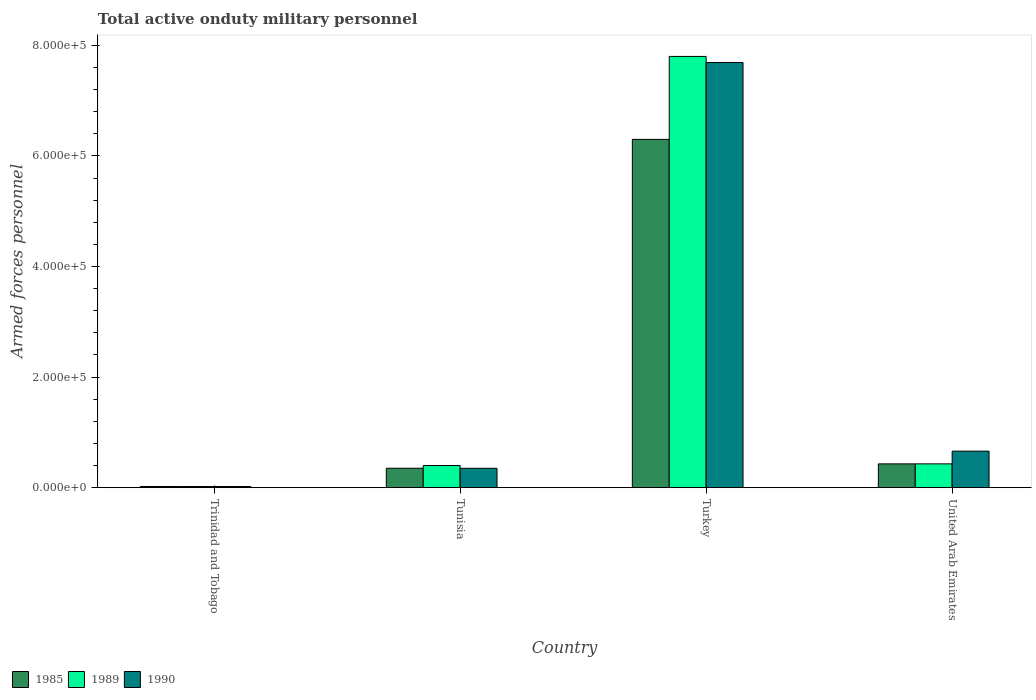How many groups of bars are there?
Provide a succinct answer. 4. Are the number of bars per tick equal to the number of legend labels?
Keep it short and to the point. Yes. How many bars are there on the 4th tick from the right?
Your response must be concise. 3. What is the label of the 2nd group of bars from the left?
Your answer should be very brief. Tunisia. In how many cases, is the number of bars for a given country not equal to the number of legend labels?
Keep it short and to the point. 0. What is the number of armed forces personnel in 1985 in United Arab Emirates?
Give a very brief answer. 4.30e+04. Across all countries, what is the maximum number of armed forces personnel in 1985?
Provide a succinct answer. 6.30e+05. Across all countries, what is the minimum number of armed forces personnel in 1990?
Your answer should be very brief. 2000. In which country was the number of armed forces personnel in 1990 minimum?
Make the answer very short. Trinidad and Tobago. What is the total number of armed forces personnel in 1990 in the graph?
Your response must be concise. 8.72e+05. What is the difference between the number of armed forces personnel in 1990 in Trinidad and Tobago and that in Turkey?
Your response must be concise. -7.67e+05. What is the difference between the number of armed forces personnel in 1985 in Trinidad and Tobago and the number of armed forces personnel in 1989 in United Arab Emirates?
Make the answer very short. -4.09e+04. What is the average number of armed forces personnel in 1990 per country?
Provide a succinct answer. 2.18e+05. What is the difference between the number of armed forces personnel of/in 1990 and number of armed forces personnel of/in 1989 in United Arab Emirates?
Your answer should be compact. 2.30e+04. What is the ratio of the number of armed forces personnel in 1989 in Trinidad and Tobago to that in Turkey?
Make the answer very short. 0. Is the number of armed forces personnel in 1985 in Turkey less than that in United Arab Emirates?
Provide a succinct answer. No. Is the difference between the number of armed forces personnel in 1990 in Trinidad and Tobago and United Arab Emirates greater than the difference between the number of armed forces personnel in 1989 in Trinidad and Tobago and United Arab Emirates?
Your answer should be compact. No. What is the difference between the highest and the second highest number of armed forces personnel in 1985?
Your response must be concise. 5.87e+05. What is the difference between the highest and the lowest number of armed forces personnel in 1985?
Your answer should be very brief. 6.28e+05. In how many countries, is the number of armed forces personnel in 1989 greater than the average number of armed forces personnel in 1989 taken over all countries?
Your response must be concise. 1. What does the 2nd bar from the left in United Arab Emirates represents?
Provide a succinct answer. 1989. What does the 1st bar from the right in Turkey represents?
Offer a terse response. 1990. Is it the case that in every country, the sum of the number of armed forces personnel in 1989 and number of armed forces personnel in 1990 is greater than the number of armed forces personnel in 1985?
Your answer should be very brief. Yes. How many bars are there?
Ensure brevity in your answer.  12. How many countries are there in the graph?
Your answer should be compact. 4. What is the difference between two consecutive major ticks on the Y-axis?
Make the answer very short. 2.00e+05. Where does the legend appear in the graph?
Your answer should be compact. Bottom left. What is the title of the graph?
Give a very brief answer. Total active onduty military personnel. Does "1993" appear as one of the legend labels in the graph?
Your answer should be compact. No. What is the label or title of the Y-axis?
Provide a succinct answer. Armed forces personnel. What is the Armed forces personnel in 1985 in Trinidad and Tobago?
Offer a terse response. 2100. What is the Armed forces personnel in 1990 in Trinidad and Tobago?
Your answer should be very brief. 2000. What is the Armed forces personnel in 1985 in Tunisia?
Your answer should be very brief. 3.51e+04. What is the Armed forces personnel in 1990 in Tunisia?
Ensure brevity in your answer.  3.50e+04. What is the Armed forces personnel of 1985 in Turkey?
Give a very brief answer. 6.30e+05. What is the Armed forces personnel of 1989 in Turkey?
Offer a very short reply. 7.80e+05. What is the Armed forces personnel of 1990 in Turkey?
Give a very brief answer. 7.69e+05. What is the Armed forces personnel of 1985 in United Arab Emirates?
Your answer should be very brief. 4.30e+04. What is the Armed forces personnel of 1989 in United Arab Emirates?
Offer a terse response. 4.30e+04. What is the Armed forces personnel in 1990 in United Arab Emirates?
Make the answer very short. 6.60e+04. Across all countries, what is the maximum Armed forces personnel of 1985?
Keep it short and to the point. 6.30e+05. Across all countries, what is the maximum Armed forces personnel in 1989?
Offer a terse response. 7.80e+05. Across all countries, what is the maximum Armed forces personnel in 1990?
Provide a short and direct response. 7.69e+05. Across all countries, what is the minimum Armed forces personnel of 1985?
Provide a short and direct response. 2100. Across all countries, what is the minimum Armed forces personnel in 1990?
Offer a very short reply. 2000. What is the total Armed forces personnel in 1985 in the graph?
Ensure brevity in your answer.  7.10e+05. What is the total Armed forces personnel in 1989 in the graph?
Provide a short and direct response. 8.65e+05. What is the total Armed forces personnel in 1990 in the graph?
Offer a very short reply. 8.72e+05. What is the difference between the Armed forces personnel of 1985 in Trinidad and Tobago and that in Tunisia?
Provide a succinct answer. -3.30e+04. What is the difference between the Armed forces personnel in 1989 in Trinidad and Tobago and that in Tunisia?
Make the answer very short. -3.80e+04. What is the difference between the Armed forces personnel of 1990 in Trinidad and Tobago and that in Tunisia?
Provide a short and direct response. -3.30e+04. What is the difference between the Armed forces personnel in 1985 in Trinidad and Tobago and that in Turkey?
Your answer should be compact. -6.28e+05. What is the difference between the Armed forces personnel of 1989 in Trinidad and Tobago and that in Turkey?
Your answer should be compact. -7.78e+05. What is the difference between the Armed forces personnel in 1990 in Trinidad and Tobago and that in Turkey?
Your response must be concise. -7.67e+05. What is the difference between the Armed forces personnel of 1985 in Trinidad and Tobago and that in United Arab Emirates?
Your answer should be very brief. -4.09e+04. What is the difference between the Armed forces personnel in 1989 in Trinidad and Tobago and that in United Arab Emirates?
Keep it short and to the point. -4.10e+04. What is the difference between the Armed forces personnel of 1990 in Trinidad and Tobago and that in United Arab Emirates?
Provide a short and direct response. -6.40e+04. What is the difference between the Armed forces personnel of 1985 in Tunisia and that in Turkey?
Ensure brevity in your answer.  -5.95e+05. What is the difference between the Armed forces personnel in 1989 in Tunisia and that in Turkey?
Your answer should be very brief. -7.40e+05. What is the difference between the Armed forces personnel of 1990 in Tunisia and that in Turkey?
Provide a succinct answer. -7.34e+05. What is the difference between the Armed forces personnel of 1985 in Tunisia and that in United Arab Emirates?
Your response must be concise. -7900. What is the difference between the Armed forces personnel in 1989 in Tunisia and that in United Arab Emirates?
Offer a terse response. -3000. What is the difference between the Armed forces personnel in 1990 in Tunisia and that in United Arab Emirates?
Ensure brevity in your answer.  -3.10e+04. What is the difference between the Armed forces personnel in 1985 in Turkey and that in United Arab Emirates?
Offer a very short reply. 5.87e+05. What is the difference between the Armed forces personnel in 1989 in Turkey and that in United Arab Emirates?
Give a very brief answer. 7.37e+05. What is the difference between the Armed forces personnel in 1990 in Turkey and that in United Arab Emirates?
Make the answer very short. 7.03e+05. What is the difference between the Armed forces personnel in 1985 in Trinidad and Tobago and the Armed forces personnel in 1989 in Tunisia?
Your answer should be compact. -3.79e+04. What is the difference between the Armed forces personnel in 1985 in Trinidad and Tobago and the Armed forces personnel in 1990 in Tunisia?
Keep it short and to the point. -3.29e+04. What is the difference between the Armed forces personnel in 1989 in Trinidad and Tobago and the Armed forces personnel in 1990 in Tunisia?
Provide a short and direct response. -3.30e+04. What is the difference between the Armed forces personnel of 1985 in Trinidad and Tobago and the Armed forces personnel of 1989 in Turkey?
Keep it short and to the point. -7.78e+05. What is the difference between the Armed forces personnel in 1985 in Trinidad and Tobago and the Armed forces personnel in 1990 in Turkey?
Provide a succinct answer. -7.67e+05. What is the difference between the Armed forces personnel of 1989 in Trinidad and Tobago and the Armed forces personnel of 1990 in Turkey?
Provide a short and direct response. -7.67e+05. What is the difference between the Armed forces personnel in 1985 in Trinidad and Tobago and the Armed forces personnel in 1989 in United Arab Emirates?
Your answer should be very brief. -4.09e+04. What is the difference between the Armed forces personnel of 1985 in Trinidad and Tobago and the Armed forces personnel of 1990 in United Arab Emirates?
Keep it short and to the point. -6.39e+04. What is the difference between the Armed forces personnel in 1989 in Trinidad and Tobago and the Armed forces personnel in 1990 in United Arab Emirates?
Provide a succinct answer. -6.40e+04. What is the difference between the Armed forces personnel of 1985 in Tunisia and the Armed forces personnel of 1989 in Turkey?
Provide a short and direct response. -7.45e+05. What is the difference between the Armed forces personnel of 1985 in Tunisia and the Armed forces personnel of 1990 in Turkey?
Offer a terse response. -7.34e+05. What is the difference between the Armed forces personnel of 1989 in Tunisia and the Armed forces personnel of 1990 in Turkey?
Ensure brevity in your answer.  -7.29e+05. What is the difference between the Armed forces personnel in 1985 in Tunisia and the Armed forces personnel in 1989 in United Arab Emirates?
Keep it short and to the point. -7900. What is the difference between the Armed forces personnel in 1985 in Tunisia and the Armed forces personnel in 1990 in United Arab Emirates?
Make the answer very short. -3.09e+04. What is the difference between the Armed forces personnel of 1989 in Tunisia and the Armed forces personnel of 1990 in United Arab Emirates?
Give a very brief answer. -2.60e+04. What is the difference between the Armed forces personnel of 1985 in Turkey and the Armed forces personnel of 1989 in United Arab Emirates?
Your answer should be compact. 5.87e+05. What is the difference between the Armed forces personnel in 1985 in Turkey and the Armed forces personnel in 1990 in United Arab Emirates?
Keep it short and to the point. 5.64e+05. What is the difference between the Armed forces personnel of 1989 in Turkey and the Armed forces personnel of 1990 in United Arab Emirates?
Keep it short and to the point. 7.14e+05. What is the average Armed forces personnel of 1985 per country?
Ensure brevity in your answer.  1.78e+05. What is the average Armed forces personnel in 1989 per country?
Make the answer very short. 2.16e+05. What is the average Armed forces personnel in 1990 per country?
Your response must be concise. 2.18e+05. What is the difference between the Armed forces personnel in 1985 and Armed forces personnel in 1989 in Trinidad and Tobago?
Provide a succinct answer. 100. What is the difference between the Armed forces personnel in 1989 and Armed forces personnel in 1990 in Trinidad and Tobago?
Offer a very short reply. 0. What is the difference between the Armed forces personnel in 1985 and Armed forces personnel in 1989 in Tunisia?
Offer a terse response. -4900. What is the difference between the Armed forces personnel in 1985 and Armed forces personnel in 1989 in Turkey?
Your answer should be compact. -1.50e+05. What is the difference between the Armed forces personnel of 1985 and Armed forces personnel of 1990 in Turkey?
Offer a very short reply. -1.39e+05. What is the difference between the Armed forces personnel in 1989 and Armed forces personnel in 1990 in Turkey?
Offer a terse response. 1.10e+04. What is the difference between the Armed forces personnel in 1985 and Armed forces personnel in 1989 in United Arab Emirates?
Provide a short and direct response. 0. What is the difference between the Armed forces personnel of 1985 and Armed forces personnel of 1990 in United Arab Emirates?
Your response must be concise. -2.30e+04. What is the difference between the Armed forces personnel of 1989 and Armed forces personnel of 1990 in United Arab Emirates?
Your response must be concise. -2.30e+04. What is the ratio of the Armed forces personnel in 1985 in Trinidad and Tobago to that in Tunisia?
Your response must be concise. 0.06. What is the ratio of the Armed forces personnel of 1989 in Trinidad and Tobago to that in Tunisia?
Provide a short and direct response. 0.05. What is the ratio of the Armed forces personnel in 1990 in Trinidad and Tobago to that in Tunisia?
Provide a short and direct response. 0.06. What is the ratio of the Armed forces personnel of 1985 in Trinidad and Tobago to that in Turkey?
Offer a very short reply. 0. What is the ratio of the Armed forces personnel in 1989 in Trinidad and Tobago to that in Turkey?
Keep it short and to the point. 0. What is the ratio of the Armed forces personnel in 1990 in Trinidad and Tobago to that in Turkey?
Offer a very short reply. 0. What is the ratio of the Armed forces personnel in 1985 in Trinidad and Tobago to that in United Arab Emirates?
Provide a succinct answer. 0.05. What is the ratio of the Armed forces personnel in 1989 in Trinidad and Tobago to that in United Arab Emirates?
Provide a succinct answer. 0.05. What is the ratio of the Armed forces personnel of 1990 in Trinidad and Tobago to that in United Arab Emirates?
Ensure brevity in your answer.  0.03. What is the ratio of the Armed forces personnel in 1985 in Tunisia to that in Turkey?
Provide a short and direct response. 0.06. What is the ratio of the Armed forces personnel of 1989 in Tunisia to that in Turkey?
Make the answer very short. 0.05. What is the ratio of the Armed forces personnel in 1990 in Tunisia to that in Turkey?
Ensure brevity in your answer.  0.05. What is the ratio of the Armed forces personnel in 1985 in Tunisia to that in United Arab Emirates?
Offer a very short reply. 0.82. What is the ratio of the Armed forces personnel in 1989 in Tunisia to that in United Arab Emirates?
Your answer should be compact. 0.93. What is the ratio of the Armed forces personnel of 1990 in Tunisia to that in United Arab Emirates?
Your answer should be very brief. 0.53. What is the ratio of the Armed forces personnel of 1985 in Turkey to that in United Arab Emirates?
Provide a succinct answer. 14.65. What is the ratio of the Armed forces personnel of 1989 in Turkey to that in United Arab Emirates?
Make the answer very short. 18.14. What is the ratio of the Armed forces personnel in 1990 in Turkey to that in United Arab Emirates?
Your answer should be compact. 11.65. What is the difference between the highest and the second highest Armed forces personnel in 1985?
Ensure brevity in your answer.  5.87e+05. What is the difference between the highest and the second highest Armed forces personnel in 1989?
Offer a terse response. 7.37e+05. What is the difference between the highest and the second highest Armed forces personnel of 1990?
Your response must be concise. 7.03e+05. What is the difference between the highest and the lowest Armed forces personnel of 1985?
Ensure brevity in your answer.  6.28e+05. What is the difference between the highest and the lowest Armed forces personnel in 1989?
Provide a succinct answer. 7.78e+05. What is the difference between the highest and the lowest Armed forces personnel of 1990?
Your answer should be very brief. 7.67e+05. 